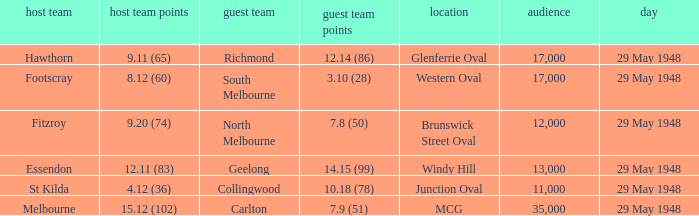During melbourne's home game, who was the away team? Carlton. 